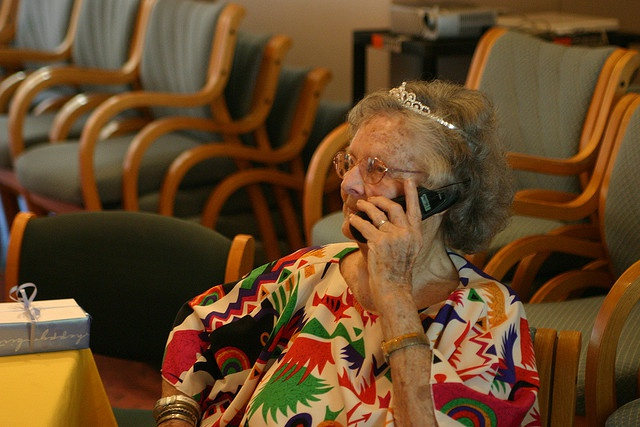Describe the objects in this image and their specific colors. I can see people in maroon, black, brown, and gray tones, chair in maroon, gray, and brown tones, chair in maroon, black, brown, and darkgreen tones, chair in maroon, olive, gray, and brown tones, and chair in maroon, black, olive, and brown tones in this image. 